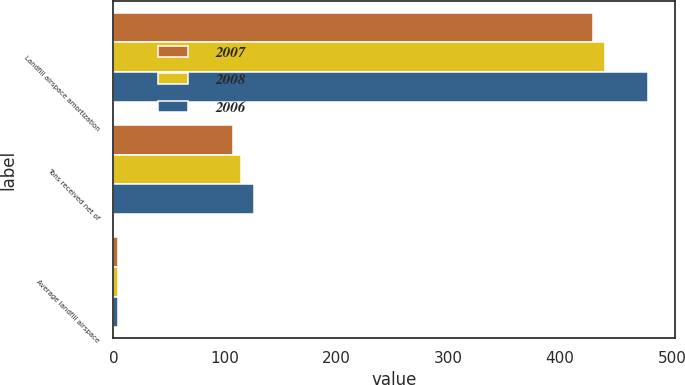Convert chart. <chart><loc_0><loc_0><loc_500><loc_500><stacked_bar_chart><ecel><fcel>Landfill airspace amortization<fcel>Tons received net of<fcel>Average landfill airspace<nl><fcel>2007<fcel>429<fcel>107<fcel>4.01<nl><fcel>2008<fcel>440<fcel>114<fcel>3.86<nl><fcel>2006<fcel>479<fcel>126<fcel>3.8<nl></chart> 